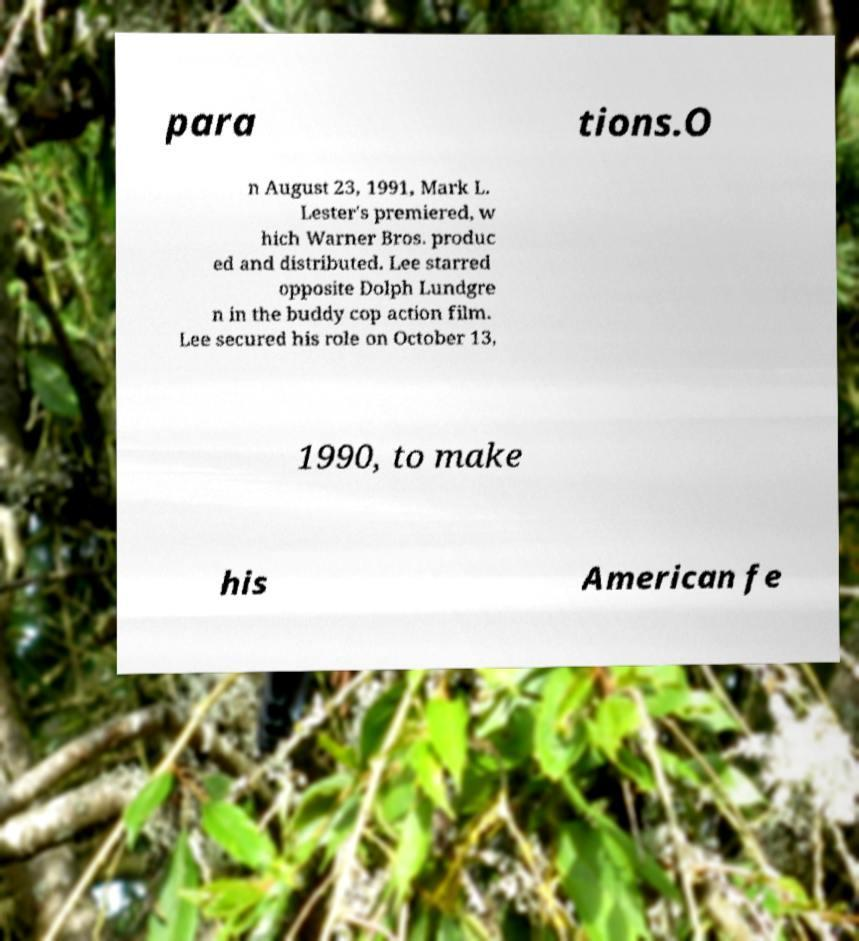There's text embedded in this image that I need extracted. Can you transcribe it verbatim? para tions.O n August 23, 1991, Mark L. Lester's premiered, w hich Warner Bros. produc ed and distributed. Lee starred opposite Dolph Lundgre n in the buddy cop action film. Lee secured his role on October 13, 1990, to make his American fe 